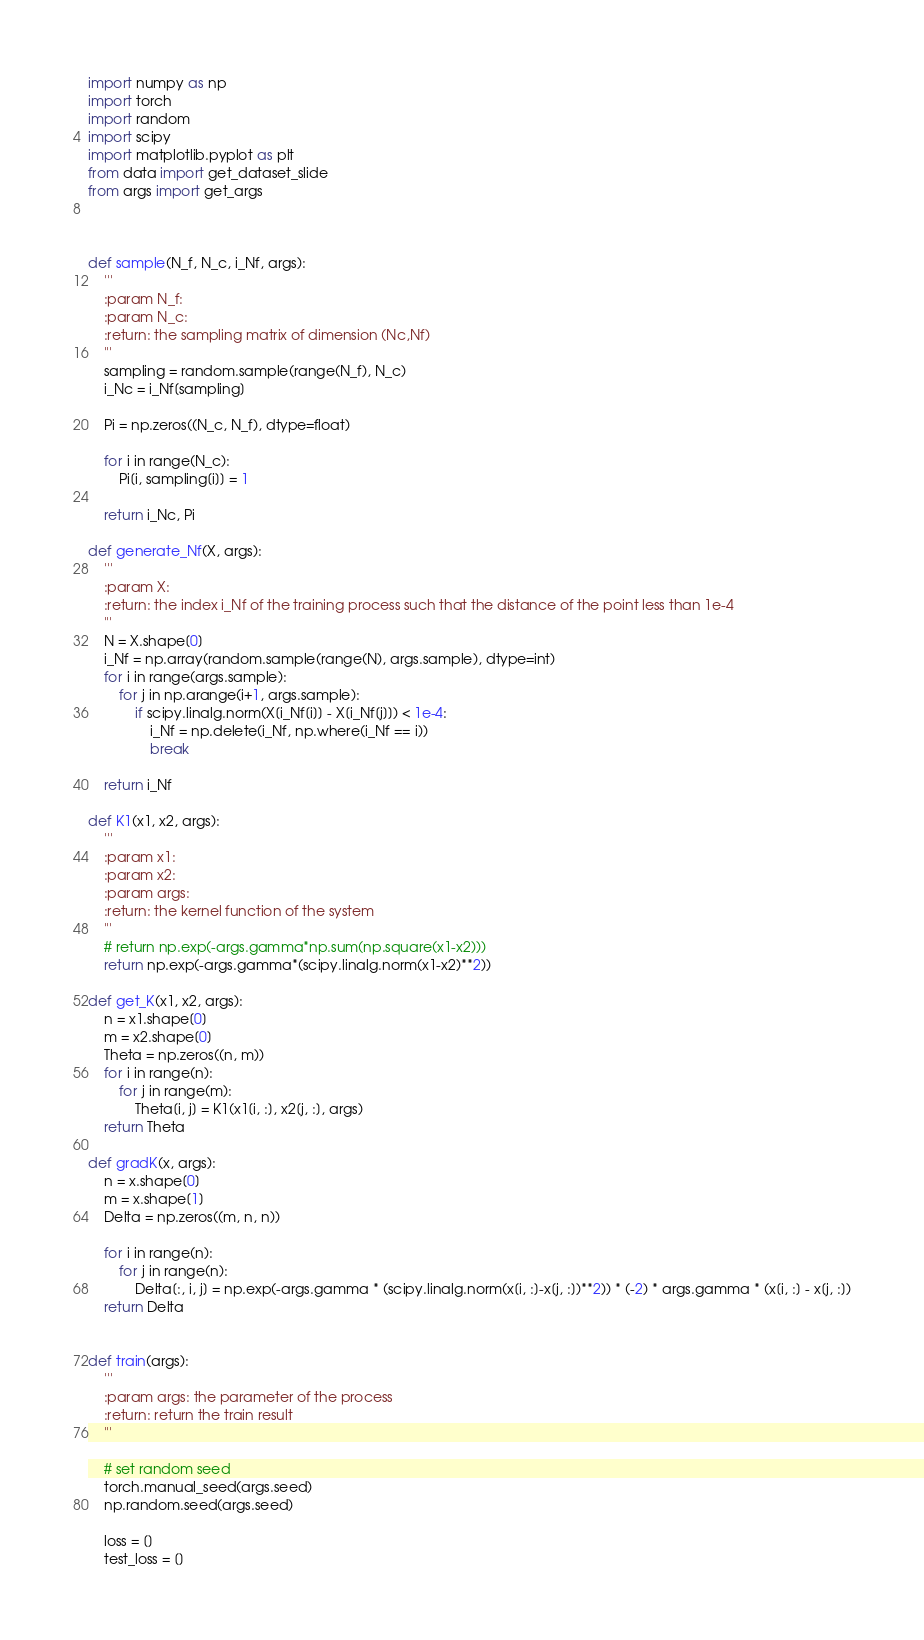Convert code to text. <code><loc_0><loc_0><loc_500><loc_500><_Python_>
import numpy as np
import torch
import random
import scipy
import matplotlib.pyplot as plt
from data import get_dataset_slide
from args import get_args



def sample(N_f, N_c, i_Nf, args):
    '''
    :param N_f:
    :param N_c:
    :return: the sampling matrix of dimension (Nc,Nf)
    '''
    sampling = random.sample(range(N_f), N_c)
    i_Nc = i_Nf[sampling]

    Pi = np.zeros((N_c, N_f), dtype=float)

    for i in range(N_c):
        Pi[i, sampling[i]] = 1

    return i_Nc, Pi

def generate_Nf(X, args):
    '''
    :param X:
    :return: the index i_Nf of the training process such that the distance of the point less than 1e-4
    '''
    N = X.shape[0]
    i_Nf = np.array(random.sample(range(N), args.sample), dtype=int)
    for i in range(args.sample):
        for j in np.arange(i+1, args.sample):
            if scipy.linalg.norm(X[i_Nf[i]] - X[i_Nf[j]]) < 1e-4:
                i_Nf = np.delete(i_Nf, np.where(i_Nf == i))
                break

    return i_Nf

def K1(x1, x2, args):
    '''
    :param x1:
    :param x2:
    :param args:
    :return: the kernel function of the system
    '''
    # return np.exp(-args.gamma*np.sum(np.square(x1-x2)))
    return np.exp(-args.gamma*(scipy.linalg.norm(x1-x2)**2))

def get_K(x1, x2, args):
    n = x1.shape[0]
    m = x2.shape[0]
    Theta = np.zeros((n, m))
    for i in range(n):
        for j in range(m):
            Theta[i, j] = K1(x1[i, :], x2[j, :], args)
    return Theta

def gradK(x, args):
    n = x.shape[0]
    m = x.shape[1]
    Delta = np.zeros((m, n, n))

    for i in range(n):
        for j in range(n):
            Delta[:, i, j] = np.exp(-args.gamma * (scipy.linalg.norm(x[i, :]-x[j, :])**2)) * (-2) * args.gamma * (x[i, :] - x[j, :])
    return Delta


def train(args):
    '''
    :param args: the parameter of the process
    :return: return the train result
    '''

    # set random seed
    torch.manual_seed(args.seed)
    np.random.seed(args.seed)

    loss = []
    test_loss = []
</code> 